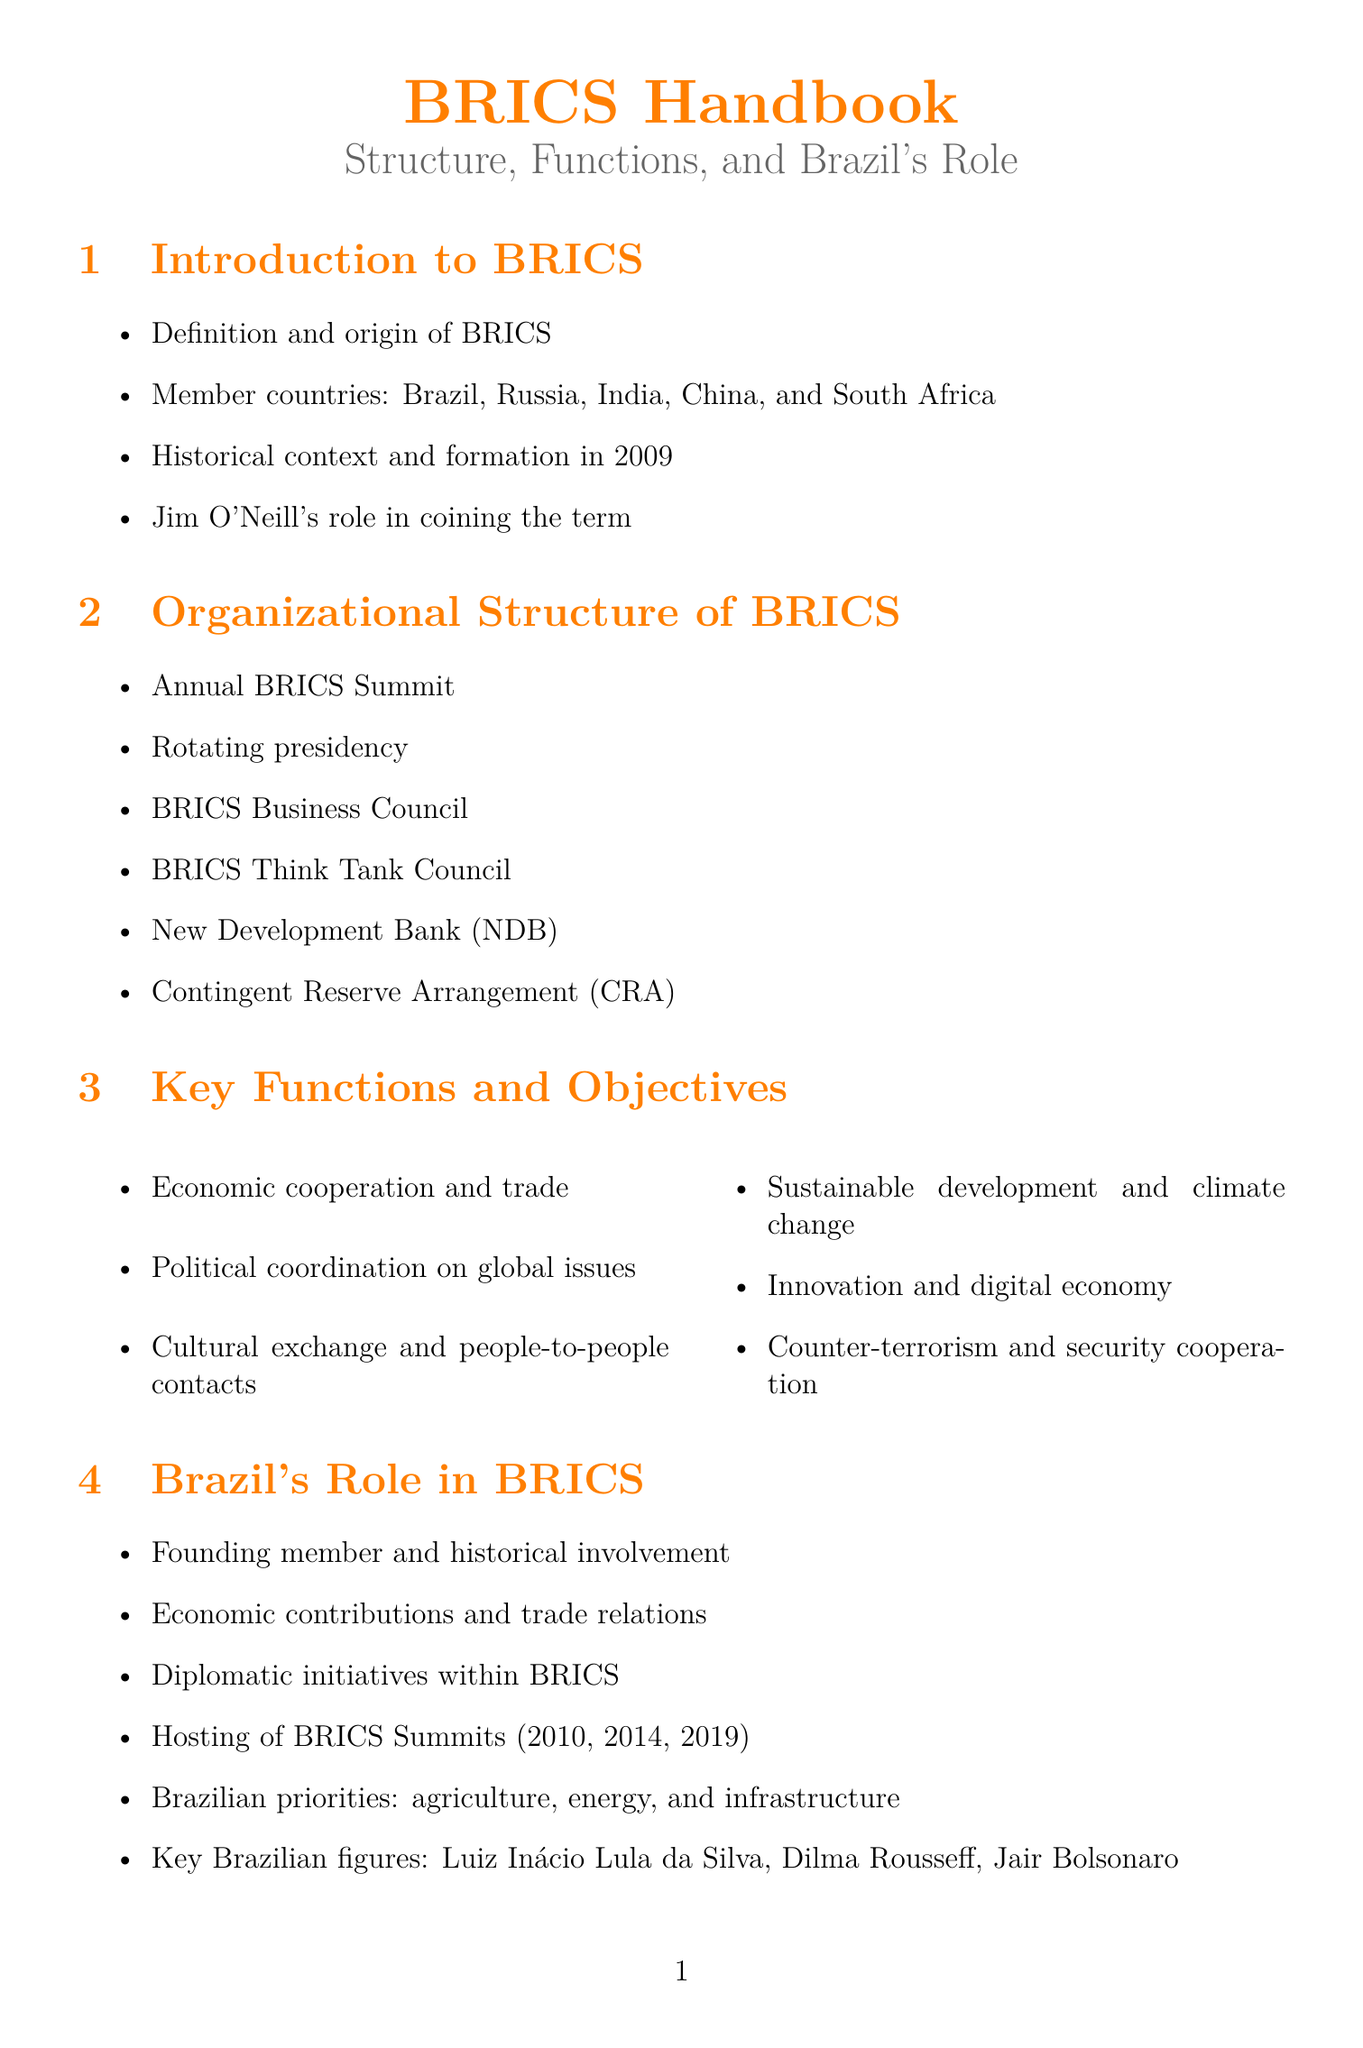what year was BRICS formed? The formation year of BRICS is mentioned in the introduction section of the document.
Answer: 2009 who coined the term BRICS? The document states that Jim O'Neill played a role in coining the term.
Answer: Jim O'Neill what is one of Brazil's key priorities in BRICS? The document highlights agriculture, energy, and infrastructure as Brazil's priorities within BRICS.
Answer: agriculture which Brazilian President hosted the BRICS Summit in 2014? The document lists key Brazilian figures and their involvement, indicating which presidents hosted different summits.
Answer: Dilma Rousseff name one initiative Brazil contributed to within BRICS. The document lists various initiatives, mentioning specific Brazilian contributions to BRICS initiatives.
Answer: New Development Bank what is the main economic interest for Brazil in BRICS? The document details Brazil's economic interests in BRICS, specifically focusing on export opportunities.
Answer: Export opportunities how many BRICS Summits did Brazil host? The document mentions the years Brazil hosted summits, providing numerical information on the total hosted.
Answer: 3 what does BRICS stand for? The introduction section of the document represents the member countries, indicating what BRICS stands for.
Answer: Brazil, Russia, India, China, South Africa 